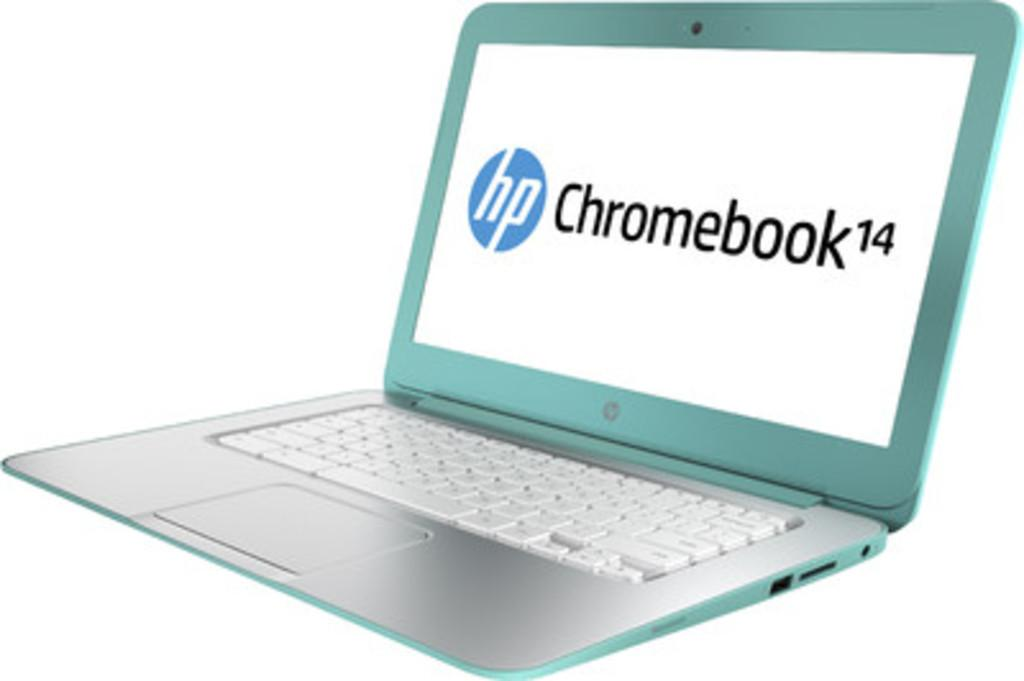What electronic device is visible in the image? There is a laptop in the image. What is written on the laptop? There is text written on the laptop. How many pigs are visible on the ground in the image? There are no pigs present in the image, and the ground is not visible. 